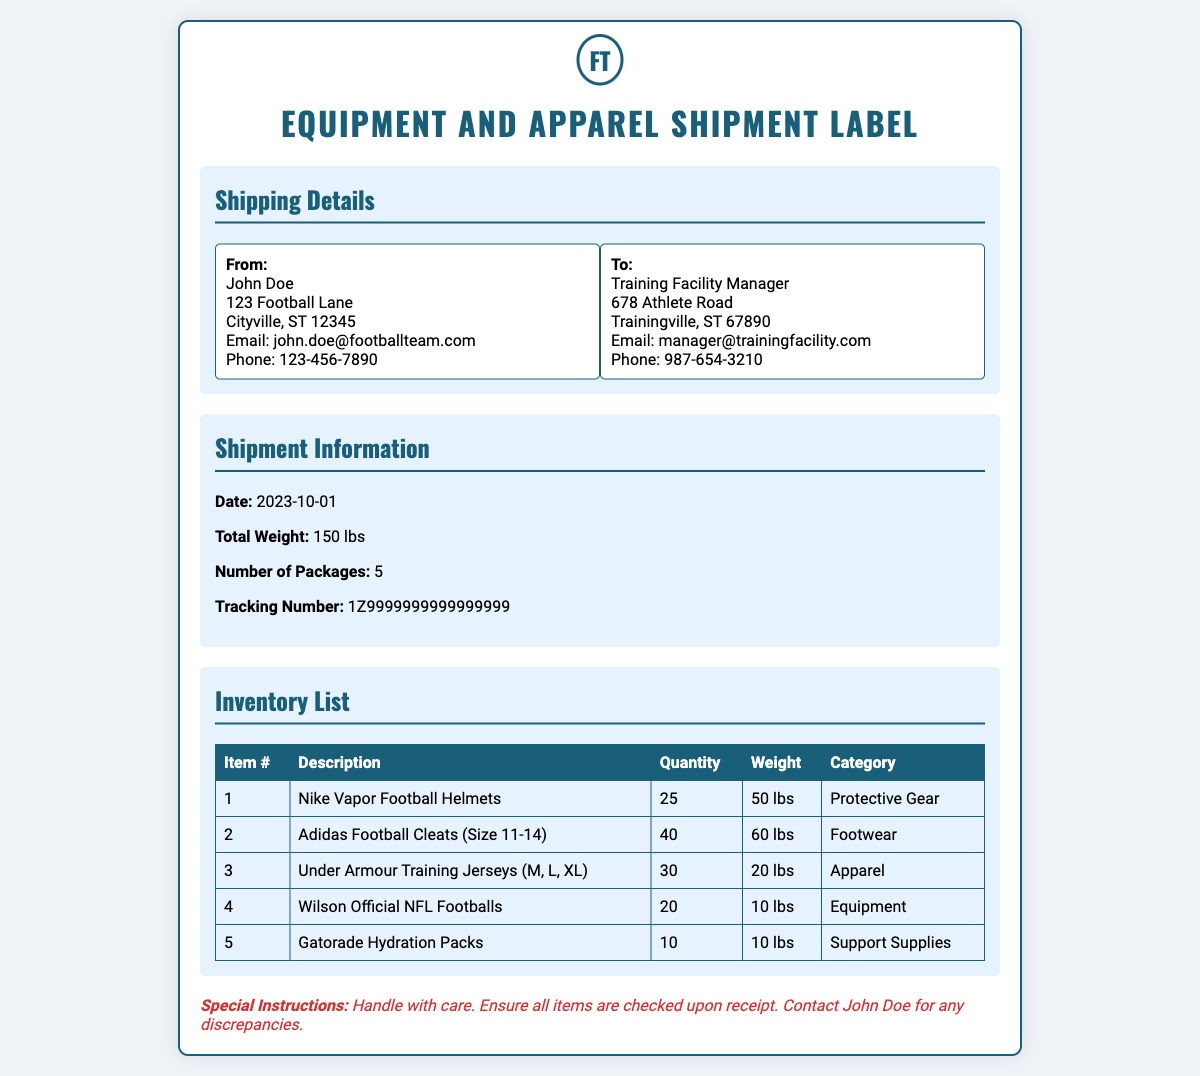what is the date of the shipment? The date of the shipment is clearly stated in the document under 'Shipment Information'.
Answer: 2023-10-01 who is the sender of the shipment? The sender's name and details are provided under 'Shipping Details' from the address block.
Answer: John Doe what is the total weight of the shipment? The total weight is mentioned in the 'Shipment Information' section of the document.
Answer: 150 lbs how many packages are being shipped? The number of packages is indicated in the 'Shipment Information'.
Answer: 5 what is the tracking number? The tracking number can be found in the 'Shipment Information' section.
Answer: 1Z9999999999999999 what type of footgear is included in the shipment? The type of footgear is listed in the 'Inventory List' under 'Description' for a specific item.
Answer: Adidas Football Cleats (Size 11-14) how many Nike Vapor Football Helmets are included? The quantity of Nike Vapor Football Helmets is specified in the 'Inventory List'.
Answer: 25 what is the special instruction for the shipment? Special instructions are noted at the end of the document for handling the shipment.
Answer: Handle with care what category does the Gatorade Hydration Packs fall under? The category for each item is indicated in the 'Inventory List'.
Answer: Support Supplies what is the weight of the Under Armour Training Jerseys? The weight of Under Armour Training Jerseys is mentioned next to the item in the 'Inventory List'.
Answer: 20 lbs 